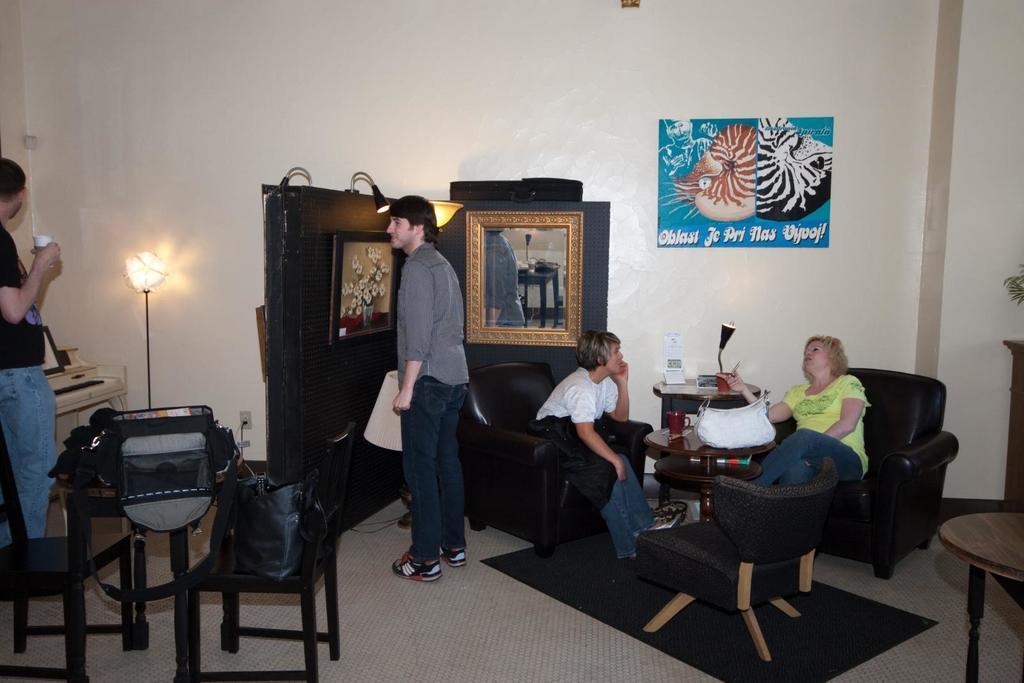In one or two sentences, can you explain what this image depicts? In this image I see 2 men standing and 2 women sitting on the sofa, I can also see few chairs, a table and bags on it. In the background I see the light, wall and a poster over here. 